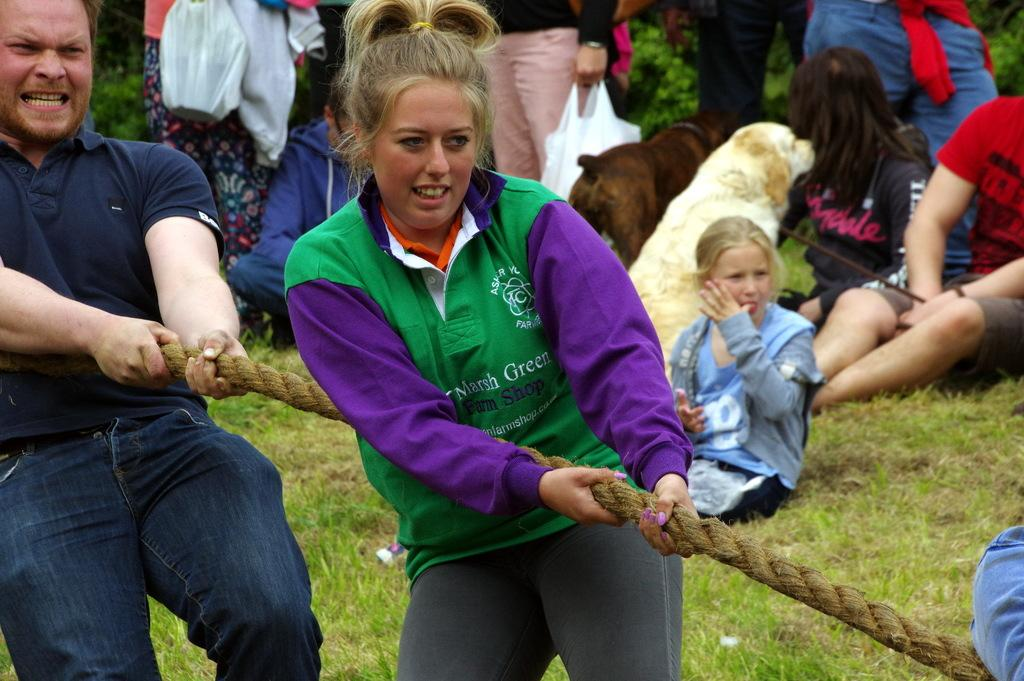What are the two main subjects in the image? There is a man and a woman in the image. What are the man and woman doing in the image? The man and woman are pulling a rope. Can you describe the background of the image? There are people in the background of the image. What type of silk fabric is being used by the man and woman in the image? There is no silk fabric present in the image; the man and woman are pulling a rope. How many apples can be seen in the image? There are no apples present in the image. 